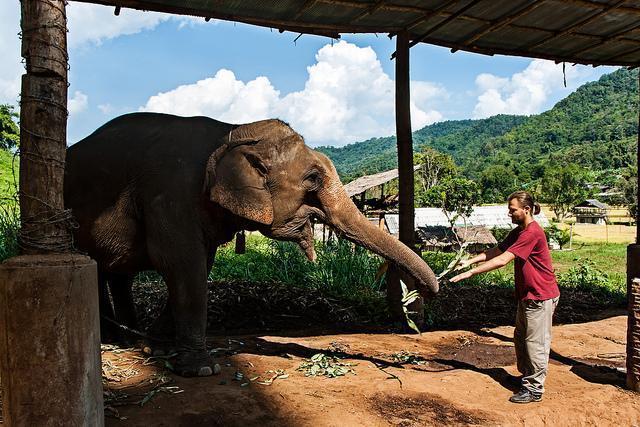How many elephants are depicted?
Give a very brief answer. 1. How many cats are sitting on the floor?
Give a very brief answer. 0. 